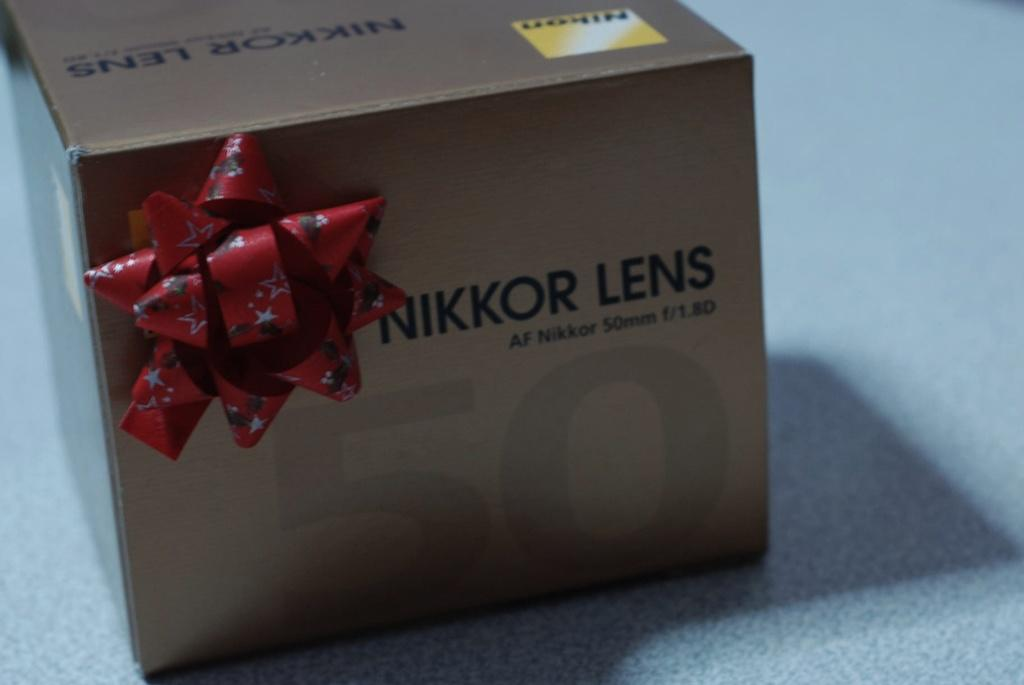Provide a one-sentence caption for the provided image. A cardboard box with a bow has the words Nikon and Nikkor Lens written on it. 